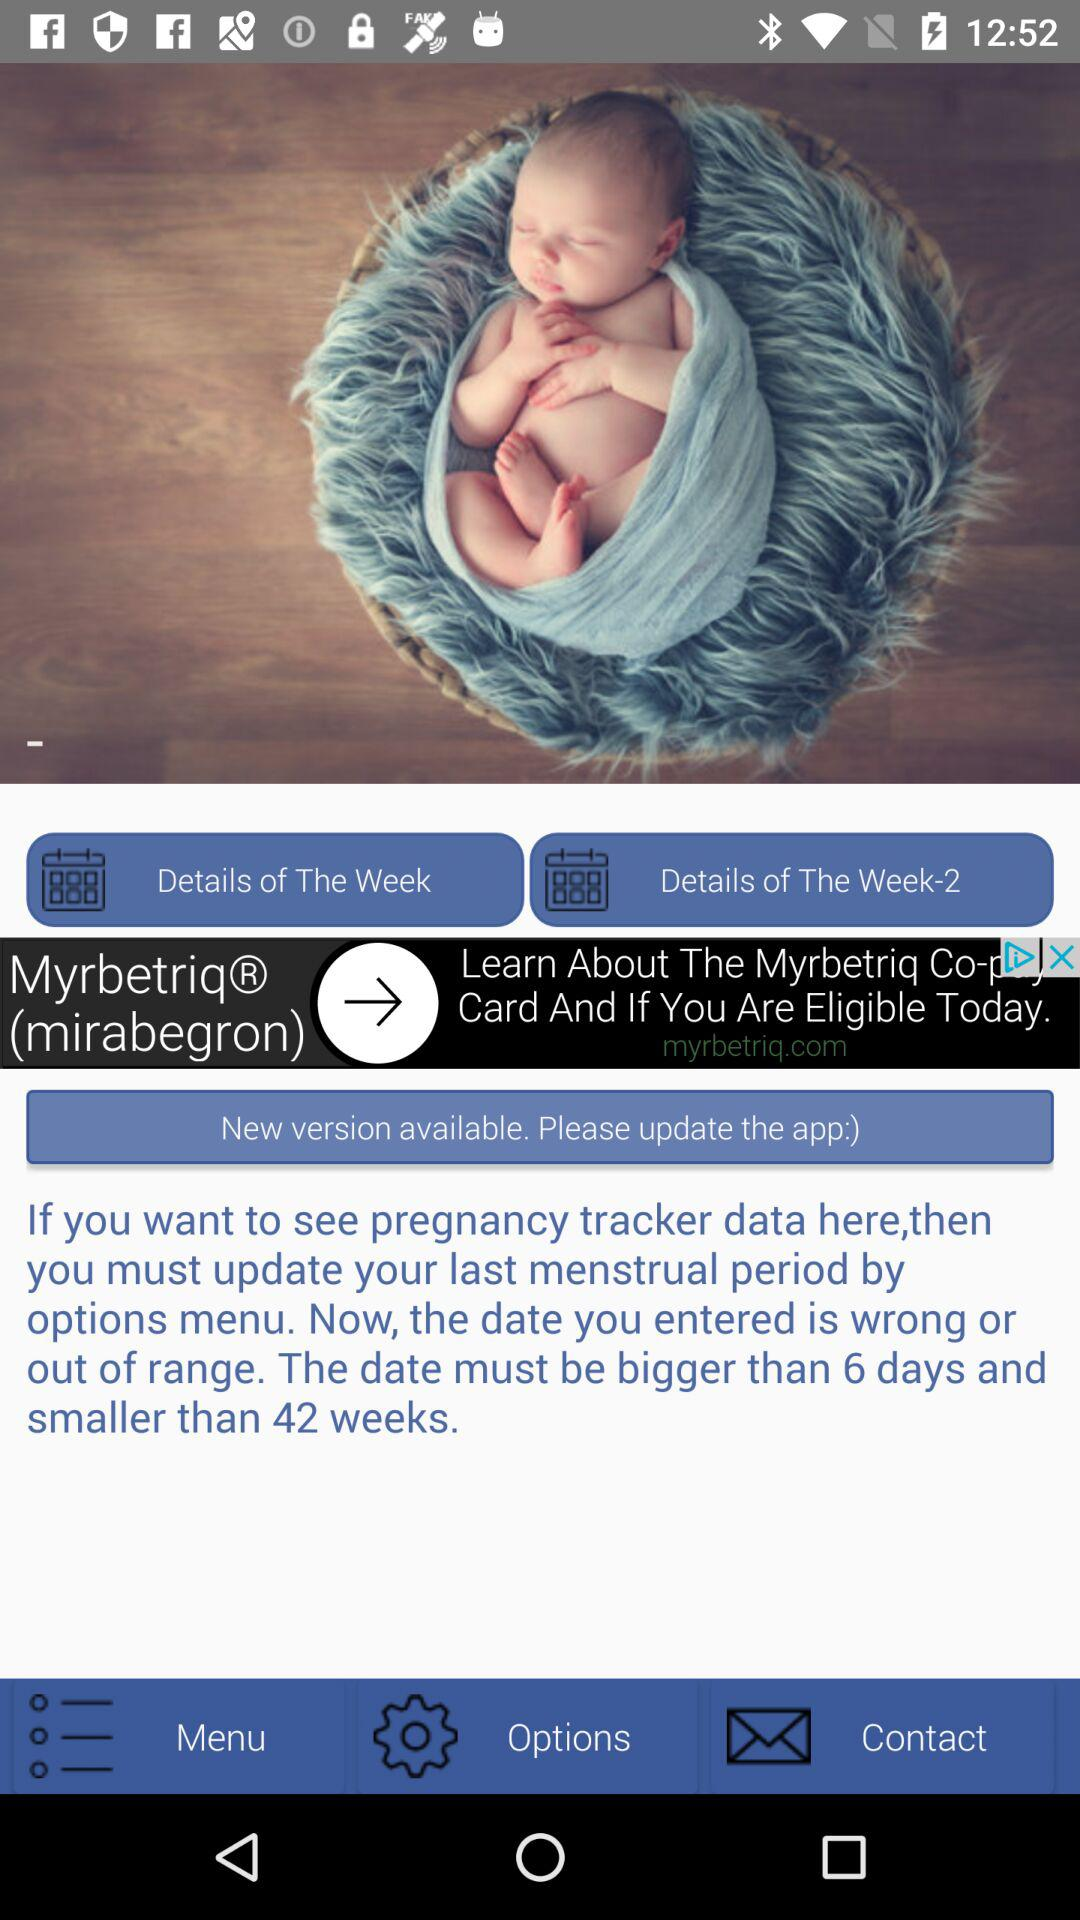What is the minimum number of days? The minimum number of days is 6. 